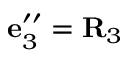<formula> <loc_0><loc_0><loc_500><loc_500>{ e } _ { 3 } ^ { \prime \prime } = { R } _ { 3 }</formula> 